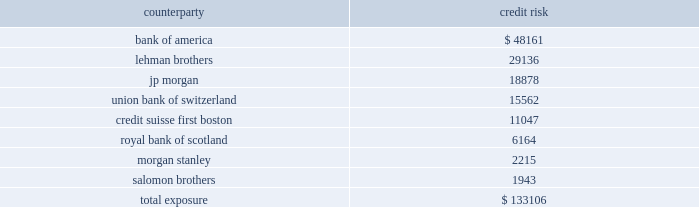Mortgage banking activities the company enters into commitments to originate loans whereby the interest rate on the loan is determined prior to funding .
These commitments are referred to as interest rate lock commitments ( 201cirlcs 201d ) .
Irlcs on loans that the company intends to sell are considered to be derivatives and are , therefore , recorded at fair value with changes in fair value recorded in earnings .
For purposes of determining fair value , the company estimates the fair value of an irlc based on the estimated fair value of the underlying mortgage loan and the probability that the mortgage loan will fund within the terms of the irlc .
The fair value excludes the market value associated with the anticipated sale of servicing rights related to each loan commitment .
The fair value of these irlcs was a $ 0.06 million and a $ 0.02 million liability at december 31 , 2007 and 2006 , respectively .
The company also designates fair value relationships of closed loans held-for-sale against a combination of mortgage forwards and short treasury positions .
Short treasury relationships are economic hedges , rather than fair value or cash flow hedges .
Short treasury positions are marked-to-market , but do not receive hedge accounting treatment under sfas no .
133 , as amended .
The mark-to-market of the mortgage forwards is included in the net change of the irlcs and the related hedging instruments .
The fair value of the mark-to-market on closed loans was a $ 1.2 thousand and $ 1.7 million asset at december 31 , 2007 and 2006 , respectively .
Irlcs , as well as closed loans held-for-sale , expose the company to interest rate risk .
The company manages this risk by selling mortgages or mortgage-backed securities on a forward basis referred to as forward sale agreements .
Changes in the fair value of these derivatives are included as gain ( loss ) on loans and securities , net in the consolidated statement of income ( loss ) .
The net change in irlcs , closed loans , mortgage forwards and the short treasury positions generated a net loss of $ 2.4 million in 2007 , a net gain of $ 1.6 million in 2006 and a net loss of $ 0.4 million in 2005 .
Credit risk credit risk is managed by limiting activity to approved counterparties and setting aggregate exposure limits for each approved counterparty .
The credit risk , or maximum exposure , which results from interest rate swaps and purchased interest rate options is represented by the fair value of contracts that have unrealized gains at the reporting date .
Conversely , we have $ 197.5 million of derivative contracts with unrealized losses at december 31 , 2007 .
The company pledged approximately $ 87.4 million of its mortgage-backed securities as collateral of derivative contracts .
While the company does not expect that any counterparty will fail to perform , the table shows the maximum exposure associated with each counterparty to interest rate swaps and purchased interest rate options at december 31 , 2007 ( dollars in thousands ) : counterparty credit .

What was the percent of the counterparty credit risk for bank of america to the total credit risk exposure? 
Rationale: 36.2% of the total risk risk exposure was associated with the counterparty risk of bank of america
Computations: (48161 / 133106)
Answer: 0.36182. 